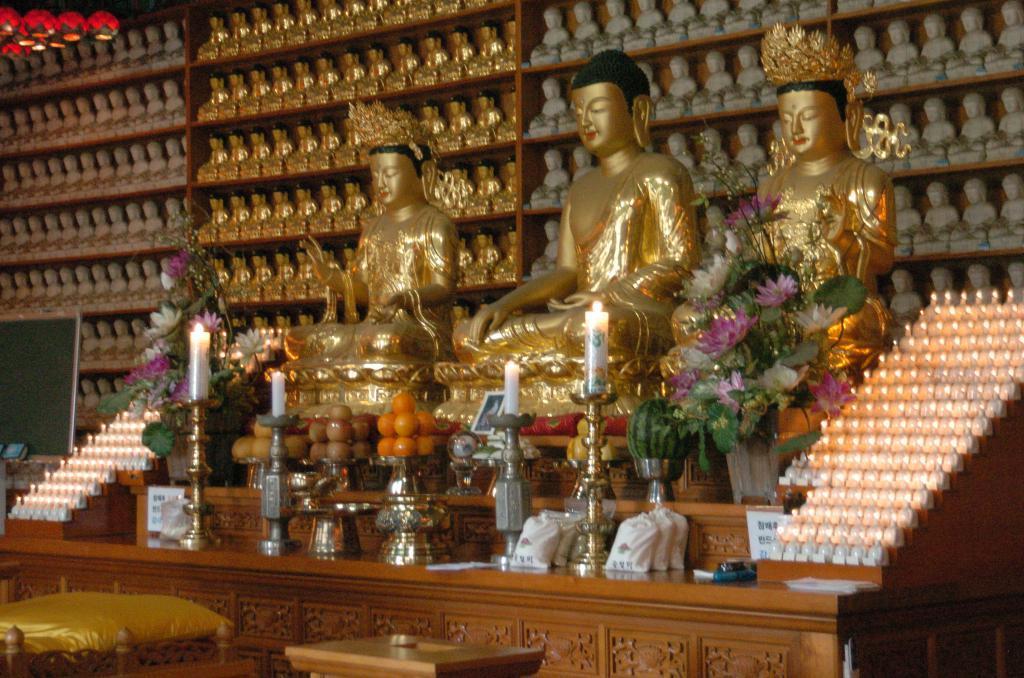In one or two sentences, can you explain what this image depicts? In this image I can see there are three idols visible on the table , in front of idols flowering plant , flower pot , fruits , candle stand, candles , small packets kept on table. in front of table there is another small table, backside of idol I can see a rack , in the rack there are small idols visible. 